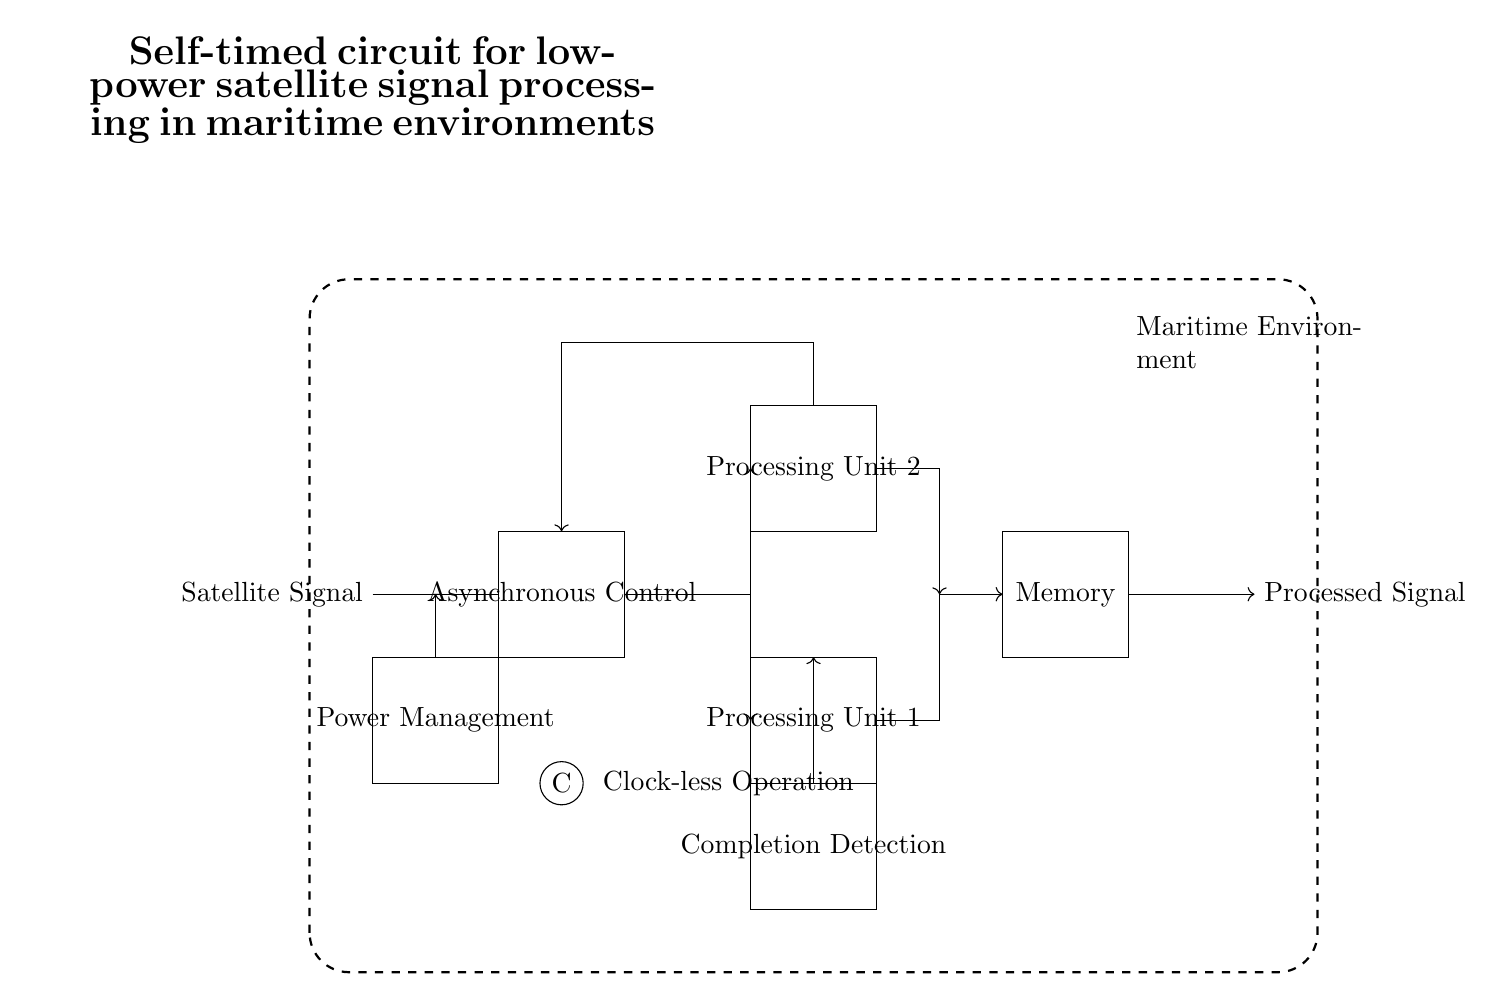What is the input to the circuit? The input to the circuit is labeled as "Satellite Signal," which indicates the source of the signal being processed.
Answer: Satellite Signal What is the main function of the "Asynchronous Control" block? The "Asynchronous Control" block coordinates operations in the circuit without reliance on a clock signal, allowing for dynamic processing based on input signals and their timing.
Answer: Coordination How many processing units are present in the circuit? There are two processing units indicated in the diagram, labeled "Processing Unit 1" and "Processing Unit 2."
Answer: Two What is the purpose of the "Completion Detection" block? The "Completion Detection" block monitors when processing is finished in the processing units, ensuring that data is only moved to memory when it is ready, thereby optimizing performance.
Answer: Monitoring How does the circuit handle power management? The "Power Management" block optimizes energy consumption throughout the operation of the circuit, ensuring low power usage which is essential for maritime applications where energy resources may be limited.
Answer: Optimization In what environment is the circuit designed to operate? The entire circuit is enclosed within a dashed rectangle labeled "Maritime Environment," indicating that it is designed for usage in marine applications, which may present unique challenges.
Answer: Maritime What is the significance of "Clock-less Operation"? "Clock-less Operation" indicates that the circuit runs without traditional clock signals, allowing for greater flexibility and potentially lower power consumption, particularly important in remote satellite operations.
Answer: Flexibility 